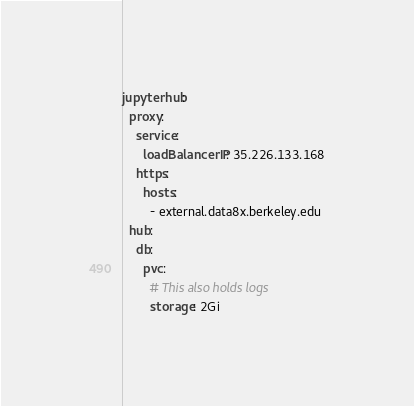Convert code to text. <code><loc_0><loc_0><loc_500><loc_500><_YAML_>jupyterhub:
  proxy:
    service:
      loadBalancerIP: 35.226.133.168
    https:
      hosts:
        - external.data8x.berkeley.edu
  hub:
    db:
      pvc:
        # This also holds logs
        storage: 2Gi
</code> 